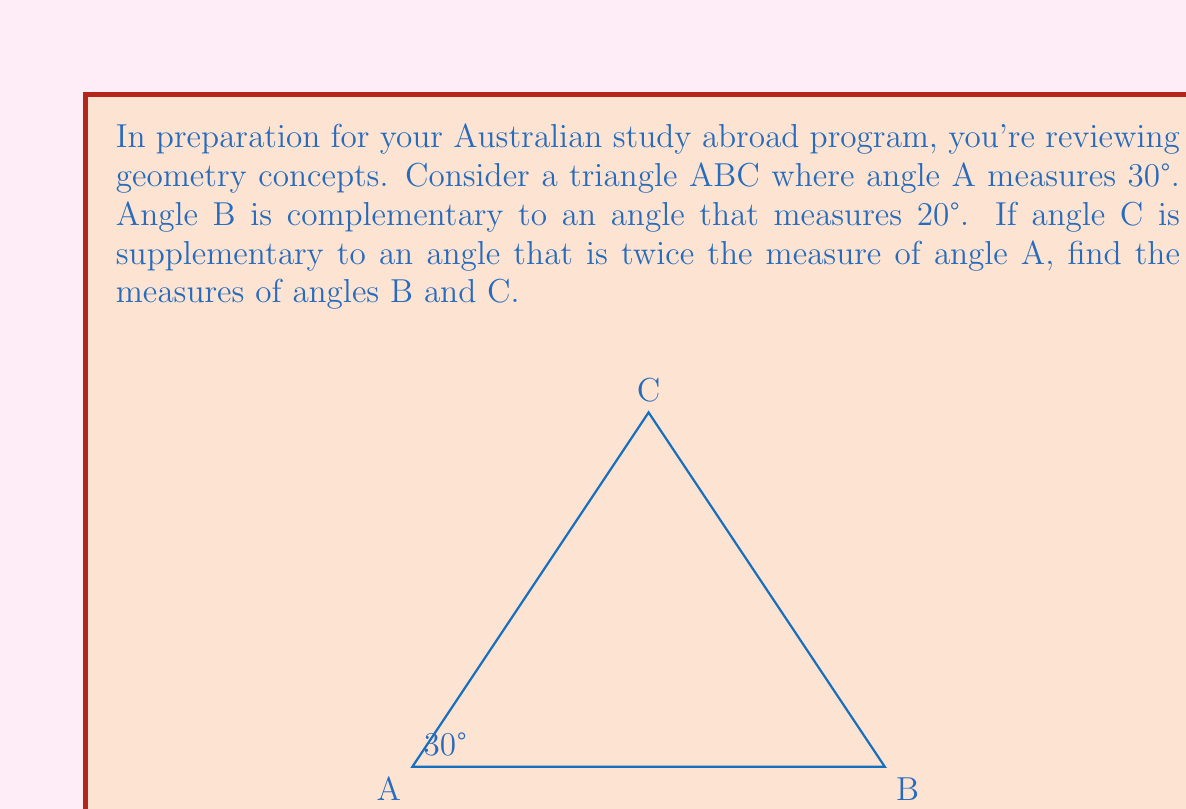Can you answer this question? Let's approach this step-by-step:

1) We're given that angle A = 30°.

2) For angle B:
   - It's complementary to an angle that measures 20°.
   - Complementary angles add up to 90°.
   - So, $\angle B = 90° - 20° = 70°$

3) For angle C:
   - It's supplementary to an angle that is twice angle A.
   - Supplementary angles add up to 180°.
   - Twice angle A is $2 * 30° = 60°$
   - So, $\angle C = 180° - 60° = 120°$

4) Let's verify that the angles of the triangle add up to 180°:
   $\angle A + \angle B + \angle C = 30° + 70° + 120° = 220°$

5) However, this sum exceeds 180°, which is impossible for a triangle. 
   This means we need to adjust our calculation for angle C.

6) The correct way to find angle C is to use the fact that the sum of angles in a triangle is 180°:
   $\angle C = 180° - \angle A - \angle B = 180° - 30° - 70° = 80°$

Therefore, $\angle B = 70°$ and $\angle C = 80°$.
Answer: $\angle B = 70°$, $\angle C = 80°$ 